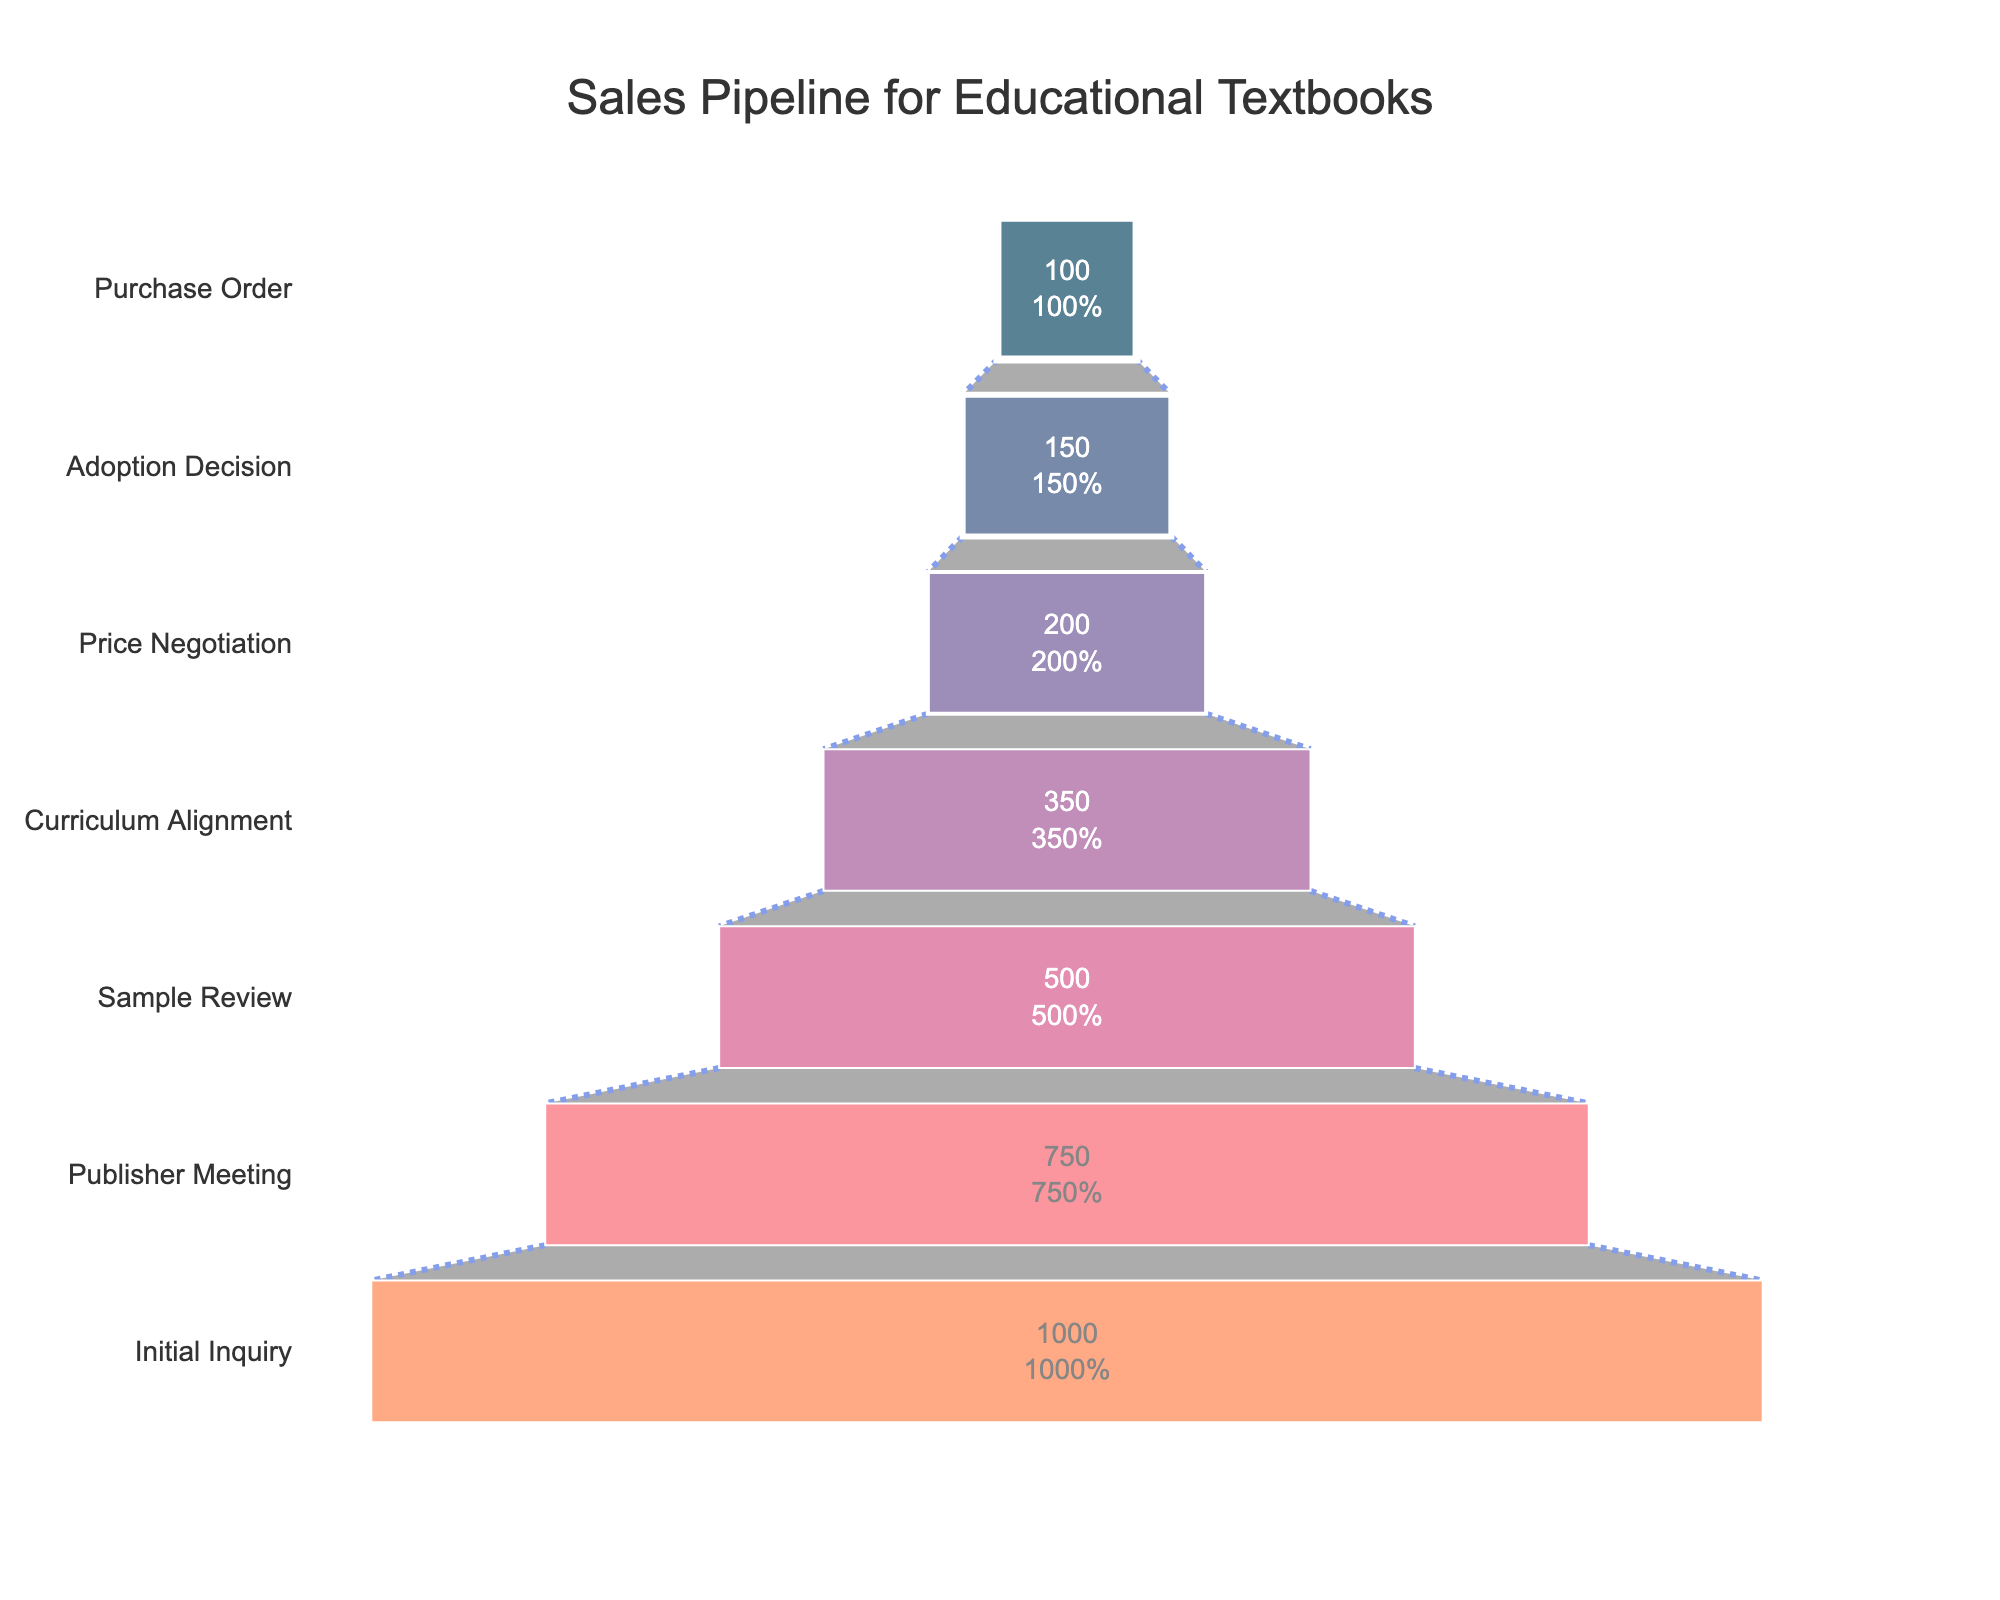what is the title of the figure? The title is usually positioned at the top of the chart. It summarizes the main content of the figure in brief words. Based on the data and context provided, the title is "Sales Pipeline for Educational Textbooks".
Answer: Sales Pipeline for Educational Textbooks How many stages are represented in the sales pipeline? To count the number of stages, observe the discrete steps listed along the y-axis of the funnel chart. There are seven stages listed: Initial Inquiry, Publisher Meeting, Sample Review, Curriculum Alignment, Price Negotiation, Adoption Decision, and Purchase Order.
Answer: 7 Which stage shows the highest number of leads? The highest number of leads is represented by the widest section at the top of the funnel. From the data, the initial inquiry stage shows the highest number of leads at 1000.
Answer: Initial Inquiry What percentage of the initial inquiries made it to the curriculum alignment stage? To find the percentage, divide the number of leads at the curriculum alignment stage (350) by the number of initial inquiries (1000) and multiply by 100. Calculation: (350/1000) * 100 = 35%.
Answer: 35% How many leads were lost between the sample review and price negotiation stages? The number of leads lost can be found by subtracting the number of leads in the price negotiation stage (200) from the number of leads in the sample review stage (500). Calculation: 500 - 200 = 300.
Answer: 300 Compare the number of leads between the adoption decision and publisher meeting stages. Which stage has more leads? To compare the two stages, look at their respective sections in the funnel chart. Adoption decision has 150 leads and publisher meeting has 750 leads. Therefore, the publisher meeting stage has more leads.
Answer: Publisher Meeting What is the decrease in percentage of leads from stage to stage from initial inquiry to purchase order? Calculate the percentage decrease at each transition and find the pattern, if any. For each stage-to-stage: 
- Initial Inquiry to Publisher Meeting: ((1000-750)/1000)*100 = 25% 
- Publisher Meeting to Sample Review: ((750-500)/750)*100 = 33.33%
- Sample Review to Curriculum Alignment: ((500-350)/500)*100 = 30%
- Curriculum Alignment to Price Negotiation: ((350-200)/350)*100 = 42.86%
- Price Negotiation to Adoption Decision: ((200-150)/200)*100 = 25%
- Adoption Decision to Purchase Order: ((150-100)/150)*100 = 33.33%.
Answer: Varies Which stage shows a decrease in leads by half compared to the previous stage? Examine each stage's lead count and check if it's approximately 50% less than the previous stage's lead count. Curriculum Alignment to Price Negotiation shows a decrease from 350 to 200, which is not half. Sample Review to Curriculum Alignment is from 500 to 350, which is also not half. Price Negotiation to Adoption Decision from 200 to 150 indicates a 50 lead decrease but not half. None of the stages show exactly a 50% decrease.
Answer: None 